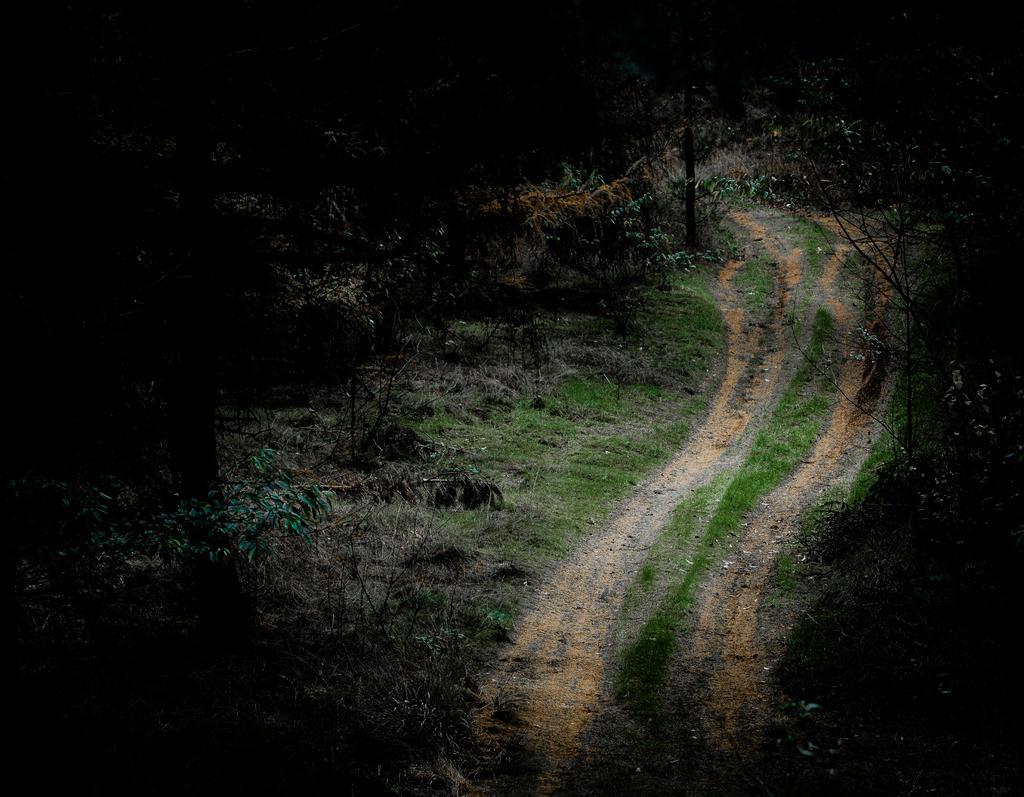Can you describe this image briefly? In the center of the image we can see a walk way. On the right side of the image we can see trees and plants. On the left side of the image there are trees and plants. 